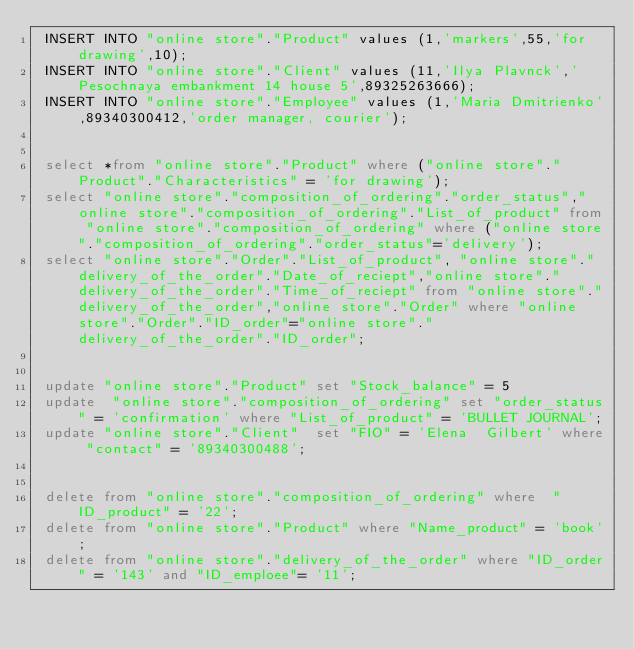Convert code to text. <code><loc_0><loc_0><loc_500><loc_500><_SQL_> INSERT INTO "online store"."Product" values (1,'markers',55,'for drawing',10);
 INSERT INTO "online store"."Client" values (11,'Ilya Plavnck','Pesochnaya embankment 14 house 5',89325263666);
 INSERT INTO "online store"."Employee" values (1,'Maria Dmitrienko',89340300412,'order manager, courier');


 select *from "online store"."Product" where ("online store"."Product"."Characteristics" = 'for drawing');
 select "online store"."composition_of_ordering"."order_status","online store"."composition_of_ordering"."List_of_product" from "online store"."composition_of_ordering" where ("online store"."composition_of_ordering"."order_status"='delivery');
 select "online store"."Order"."List_of_product", "online store"."delivery_of_the_order"."Date_of_reciept","online store"."delivery_of_the_order"."Time_of_reciept" from "online store"."delivery_of_the_order","online store"."Order" where "online store"."Order"."ID_order"="online store"."delivery_of_the_order"."ID_order";
 
 
 update "online store"."Product" set "Stock_balance" = 5 
 update  "online store"."composition_of_ordering" set "order_status" = 'confirmation' where "List_of_product" = 'BULLET JOURNAL';
 update "online store"."Client"  set "FIO" = 'Elena  Gilbert' where "contact" = '89340300488';


 delete from "online store"."composition_of_ordering" where  "ID_product" = '22';
 delete from "online store"."Product" where "Name_product" = 'book';
 delete from "online store"."delivery_of_the_order" where "ID_order" = '143' and "ID_emploee"= '11';</code> 